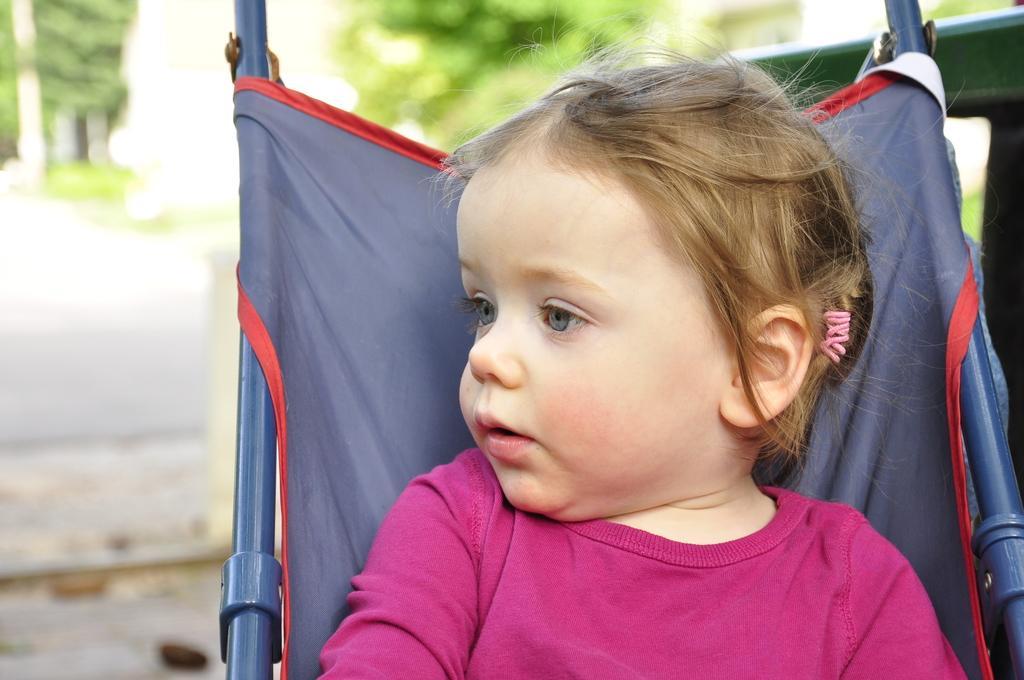Describe this image in one or two sentences. In this image there is one kid is sitting on an object as we can see on the right side of this image and there is a tree on the top of this image. 